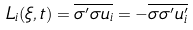Convert formula to latex. <formula><loc_0><loc_0><loc_500><loc_500>L _ { i } ( \xi , t ) = \overline { \sigma ^ { \prime } \sigma u _ { i } } = - \overline { \sigma \sigma ^ { \prime } u _ { i } ^ { \prime } }</formula> 